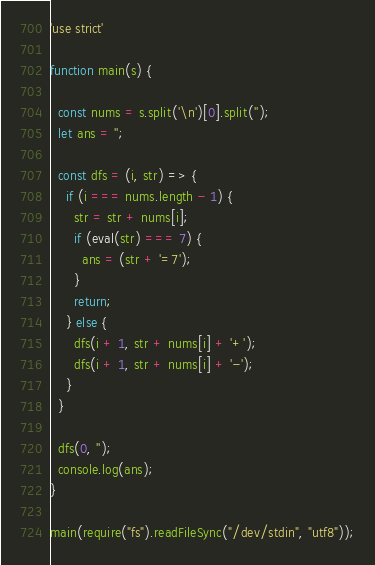Convert code to text. <code><loc_0><loc_0><loc_500><loc_500><_JavaScript_>'use strict'

function main(s) {

  const nums = s.split('\n')[0].split('');
  let ans = '';

  const dfs = (i, str) => {
    if (i === nums.length - 1) {
      str = str + nums[i];
      if (eval(str) === 7) {
        ans = (str + '=7');
      }
      return;
    } else {
      dfs(i + 1, str + nums[i] + '+');
      dfs(i + 1, str + nums[i] + '-');
    }
  }

  dfs(0, '');
  console.log(ans);
}

main(require("fs").readFileSync("/dev/stdin", "utf8"));
</code> 